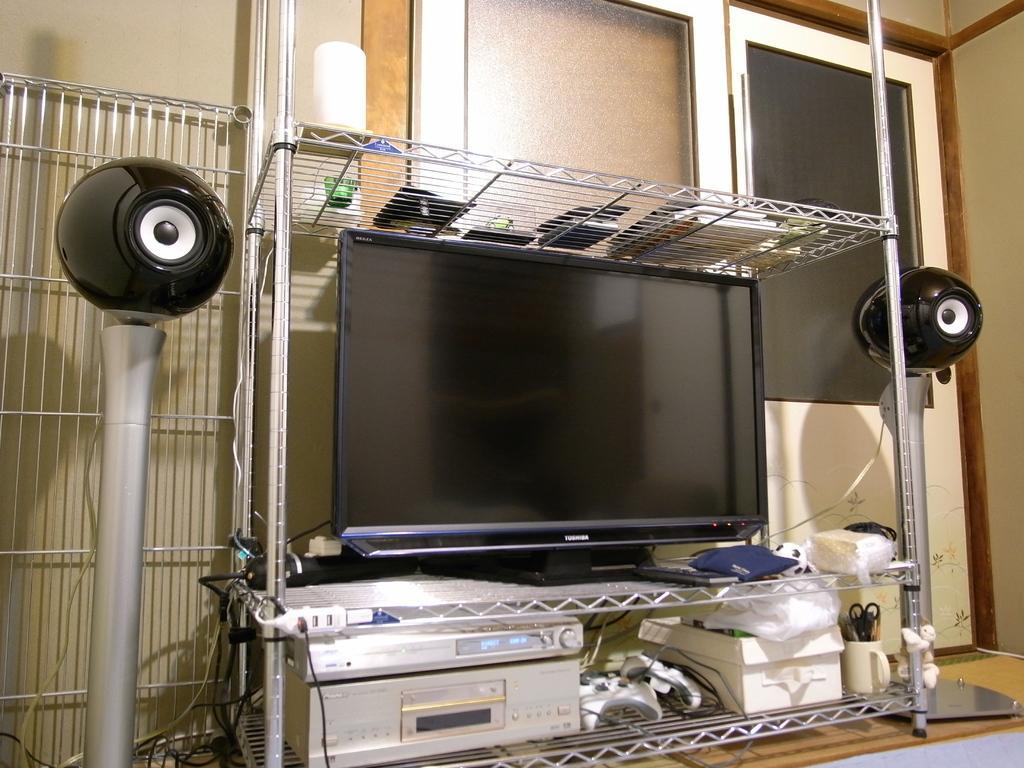Could you give a brief overview of what you see in this image? This image consists of a TV along with speakers. At the bottom, there is a CD player. These all are kept in a stand. On the right, we can see a door. At the bottom, there is a floor. 